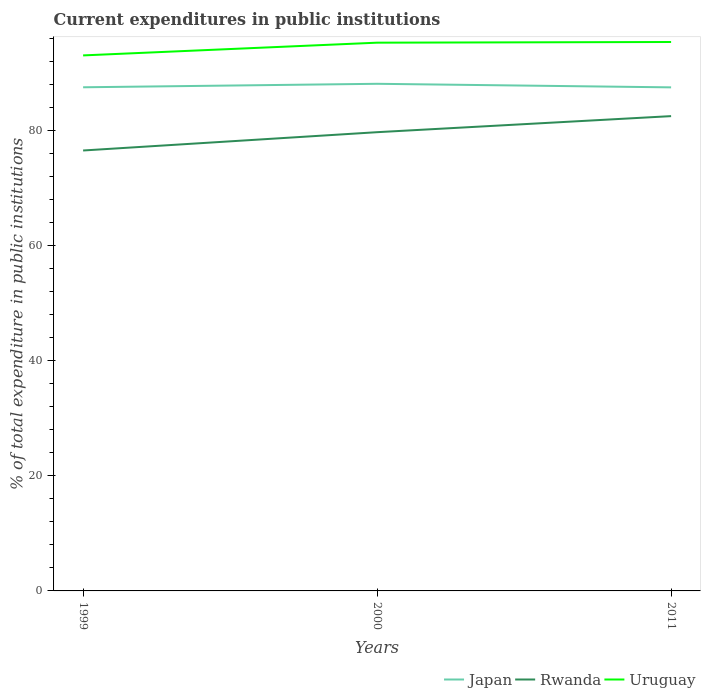How many different coloured lines are there?
Ensure brevity in your answer.  3. Across all years, what is the maximum current expenditures in public institutions in Rwanda?
Offer a very short reply. 76.52. What is the total current expenditures in public institutions in Japan in the graph?
Give a very brief answer. 0.01. What is the difference between the highest and the second highest current expenditures in public institutions in Rwanda?
Keep it short and to the point. 5.97. How many lines are there?
Offer a very short reply. 3. What is the difference between two consecutive major ticks on the Y-axis?
Your response must be concise. 20. Where does the legend appear in the graph?
Provide a succinct answer. Bottom right. What is the title of the graph?
Keep it short and to the point. Current expenditures in public institutions. What is the label or title of the X-axis?
Offer a very short reply. Years. What is the label or title of the Y-axis?
Your response must be concise. % of total expenditure in public institutions. What is the % of total expenditure in public institutions of Japan in 1999?
Your answer should be compact. 87.51. What is the % of total expenditure in public institutions in Rwanda in 1999?
Give a very brief answer. 76.52. What is the % of total expenditure in public institutions in Uruguay in 1999?
Make the answer very short. 93.04. What is the % of total expenditure in public institutions in Japan in 2000?
Provide a succinct answer. 88.11. What is the % of total expenditure in public institutions in Rwanda in 2000?
Make the answer very short. 79.7. What is the % of total expenditure in public institutions of Uruguay in 2000?
Provide a succinct answer. 95.25. What is the % of total expenditure in public institutions in Japan in 2011?
Your answer should be compact. 87.49. What is the % of total expenditure in public institutions in Rwanda in 2011?
Offer a very short reply. 82.49. What is the % of total expenditure in public institutions in Uruguay in 2011?
Offer a very short reply. 95.37. Across all years, what is the maximum % of total expenditure in public institutions in Japan?
Your answer should be compact. 88.11. Across all years, what is the maximum % of total expenditure in public institutions of Rwanda?
Provide a succinct answer. 82.49. Across all years, what is the maximum % of total expenditure in public institutions of Uruguay?
Provide a short and direct response. 95.37. Across all years, what is the minimum % of total expenditure in public institutions of Japan?
Your answer should be compact. 87.49. Across all years, what is the minimum % of total expenditure in public institutions of Rwanda?
Offer a very short reply. 76.52. Across all years, what is the minimum % of total expenditure in public institutions of Uruguay?
Offer a very short reply. 93.04. What is the total % of total expenditure in public institutions in Japan in the graph?
Provide a short and direct response. 263.11. What is the total % of total expenditure in public institutions in Rwanda in the graph?
Offer a terse response. 238.72. What is the total % of total expenditure in public institutions of Uruguay in the graph?
Offer a very short reply. 283.67. What is the difference between the % of total expenditure in public institutions of Japan in 1999 and that in 2000?
Keep it short and to the point. -0.6. What is the difference between the % of total expenditure in public institutions of Rwanda in 1999 and that in 2000?
Ensure brevity in your answer.  -3.18. What is the difference between the % of total expenditure in public institutions in Uruguay in 1999 and that in 2000?
Your answer should be very brief. -2.21. What is the difference between the % of total expenditure in public institutions of Japan in 1999 and that in 2011?
Give a very brief answer. 0.01. What is the difference between the % of total expenditure in public institutions in Rwanda in 1999 and that in 2011?
Keep it short and to the point. -5.97. What is the difference between the % of total expenditure in public institutions in Uruguay in 1999 and that in 2011?
Keep it short and to the point. -2.33. What is the difference between the % of total expenditure in public institutions in Japan in 2000 and that in 2011?
Give a very brief answer. 0.62. What is the difference between the % of total expenditure in public institutions in Rwanda in 2000 and that in 2011?
Your answer should be very brief. -2.79. What is the difference between the % of total expenditure in public institutions of Uruguay in 2000 and that in 2011?
Ensure brevity in your answer.  -0.12. What is the difference between the % of total expenditure in public institutions in Japan in 1999 and the % of total expenditure in public institutions in Rwanda in 2000?
Provide a short and direct response. 7.8. What is the difference between the % of total expenditure in public institutions of Japan in 1999 and the % of total expenditure in public institutions of Uruguay in 2000?
Offer a terse response. -7.75. What is the difference between the % of total expenditure in public institutions in Rwanda in 1999 and the % of total expenditure in public institutions in Uruguay in 2000?
Provide a short and direct response. -18.73. What is the difference between the % of total expenditure in public institutions of Japan in 1999 and the % of total expenditure in public institutions of Rwanda in 2011?
Your answer should be very brief. 5.01. What is the difference between the % of total expenditure in public institutions of Japan in 1999 and the % of total expenditure in public institutions of Uruguay in 2011?
Offer a very short reply. -7.87. What is the difference between the % of total expenditure in public institutions of Rwanda in 1999 and the % of total expenditure in public institutions of Uruguay in 2011?
Your answer should be very brief. -18.85. What is the difference between the % of total expenditure in public institutions of Japan in 2000 and the % of total expenditure in public institutions of Rwanda in 2011?
Offer a very short reply. 5.62. What is the difference between the % of total expenditure in public institutions of Japan in 2000 and the % of total expenditure in public institutions of Uruguay in 2011?
Your answer should be very brief. -7.26. What is the difference between the % of total expenditure in public institutions in Rwanda in 2000 and the % of total expenditure in public institutions in Uruguay in 2011?
Offer a very short reply. -15.67. What is the average % of total expenditure in public institutions in Japan per year?
Give a very brief answer. 87.7. What is the average % of total expenditure in public institutions in Rwanda per year?
Offer a terse response. 79.57. What is the average % of total expenditure in public institutions in Uruguay per year?
Offer a very short reply. 94.56. In the year 1999, what is the difference between the % of total expenditure in public institutions in Japan and % of total expenditure in public institutions in Rwanda?
Provide a succinct answer. 10.98. In the year 1999, what is the difference between the % of total expenditure in public institutions in Japan and % of total expenditure in public institutions in Uruguay?
Ensure brevity in your answer.  -5.54. In the year 1999, what is the difference between the % of total expenditure in public institutions in Rwanda and % of total expenditure in public institutions in Uruguay?
Give a very brief answer. -16.52. In the year 2000, what is the difference between the % of total expenditure in public institutions in Japan and % of total expenditure in public institutions in Rwanda?
Provide a short and direct response. 8.41. In the year 2000, what is the difference between the % of total expenditure in public institutions in Japan and % of total expenditure in public institutions in Uruguay?
Make the answer very short. -7.15. In the year 2000, what is the difference between the % of total expenditure in public institutions in Rwanda and % of total expenditure in public institutions in Uruguay?
Provide a short and direct response. -15.55. In the year 2011, what is the difference between the % of total expenditure in public institutions in Japan and % of total expenditure in public institutions in Rwanda?
Offer a very short reply. 5. In the year 2011, what is the difference between the % of total expenditure in public institutions of Japan and % of total expenditure in public institutions of Uruguay?
Ensure brevity in your answer.  -7.88. In the year 2011, what is the difference between the % of total expenditure in public institutions in Rwanda and % of total expenditure in public institutions in Uruguay?
Your response must be concise. -12.88. What is the ratio of the % of total expenditure in public institutions of Japan in 1999 to that in 2000?
Your answer should be compact. 0.99. What is the ratio of the % of total expenditure in public institutions of Rwanda in 1999 to that in 2000?
Offer a terse response. 0.96. What is the ratio of the % of total expenditure in public institutions of Uruguay in 1999 to that in 2000?
Provide a succinct answer. 0.98. What is the ratio of the % of total expenditure in public institutions in Japan in 1999 to that in 2011?
Provide a succinct answer. 1. What is the ratio of the % of total expenditure in public institutions in Rwanda in 1999 to that in 2011?
Provide a succinct answer. 0.93. What is the ratio of the % of total expenditure in public institutions of Uruguay in 1999 to that in 2011?
Give a very brief answer. 0.98. What is the ratio of the % of total expenditure in public institutions in Japan in 2000 to that in 2011?
Offer a very short reply. 1.01. What is the ratio of the % of total expenditure in public institutions in Rwanda in 2000 to that in 2011?
Your response must be concise. 0.97. What is the ratio of the % of total expenditure in public institutions of Uruguay in 2000 to that in 2011?
Ensure brevity in your answer.  1. What is the difference between the highest and the second highest % of total expenditure in public institutions in Japan?
Your answer should be very brief. 0.6. What is the difference between the highest and the second highest % of total expenditure in public institutions of Rwanda?
Your answer should be very brief. 2.79. What is the difference between the highest and the second highest % of total expenditure in public institutions in Uruguay?
Provide a short and direct response. 0.12. What is the difference between the highest and the lowest % of total expenditure in public institutions of Japan?
Ensure brevity in your answer.  0.62. What is the difference between the highest and the lowest % of total expenditure in public institutions in Rwanda?
Provide a short and direct response. 5.97. What is the difference between the highest and the lowest % of total expenditure in public institutions in Uruguay?
Offer a terse response. 2.33. 